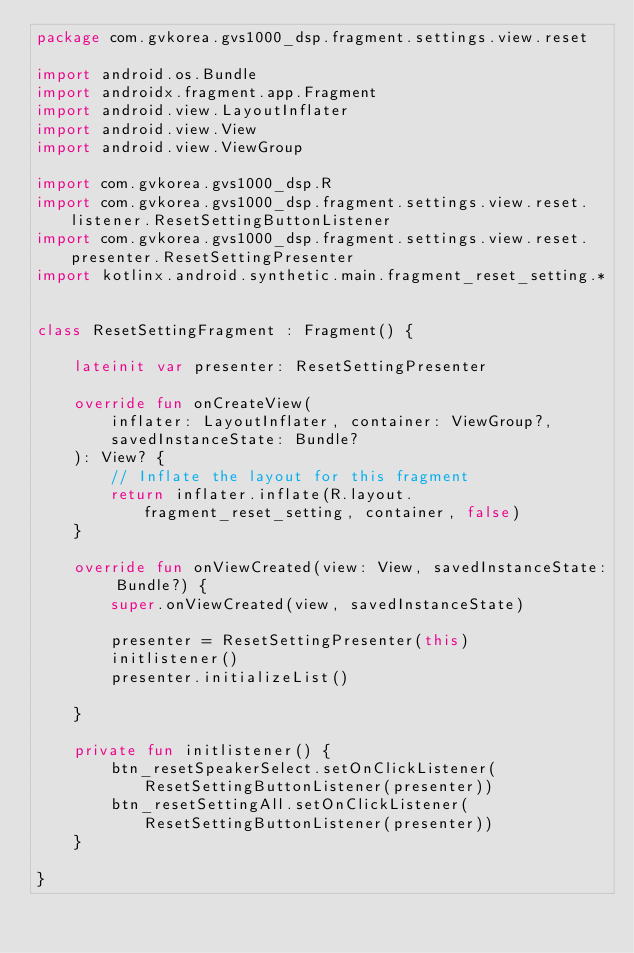<code> <loc_0><loc_0><loc_500><loc_500><_Kotlin_>package com.gvkorea.gvs1000_dsp.fragment.settings.view.reset

import android.os.Bundle
import androidx.fragment.app.Fragment
import android.view.LayoutInflater
import android.view.View
import android.view.ViewGroup

import com.gvkorea.gvs1000_dsp.R
import com.gvkorea.gvs1000_dsp.fragment.settings.view.reset.listener.ResetSettingButtonListener
import com.gvkorea.gvs1000_dsp.fragment.settings.view.reset.presenter.ResetSettingPresenter
import kotlinx.android.synthetic.main.fragment_reset_setting.*


class ResetSettingFragment : Fragment() {

    lateinit var presenter: ResetSettingPresenter

    override fun onCreateView(
        inflater: LayoutInflater, container: ViewGroup?,
        savedInstanceState: Bundle?
    ): View? {
        // Inflate the layout for this fragment
        return inflater.inflate(R.layout.fragment_reset_setting, container, false)
    }

    override fun onViewCreated(view: View, savedInstanceState: Bundle?) {
        super.onViewCreated(view, savedInstanceState)

        presenter = ResetSettingPresenter(this)
        initlistener()
        presenter.initializeList()

    }

    private fun initlistener() {
        btn_resetSpeakerSelect.setOnClickListener(ResetSettingButtonListener(presenter))
        btn_resetSettingAll.setOnClickListener(ResetSettingButtonListener(presenter))
    }

}
</code> 